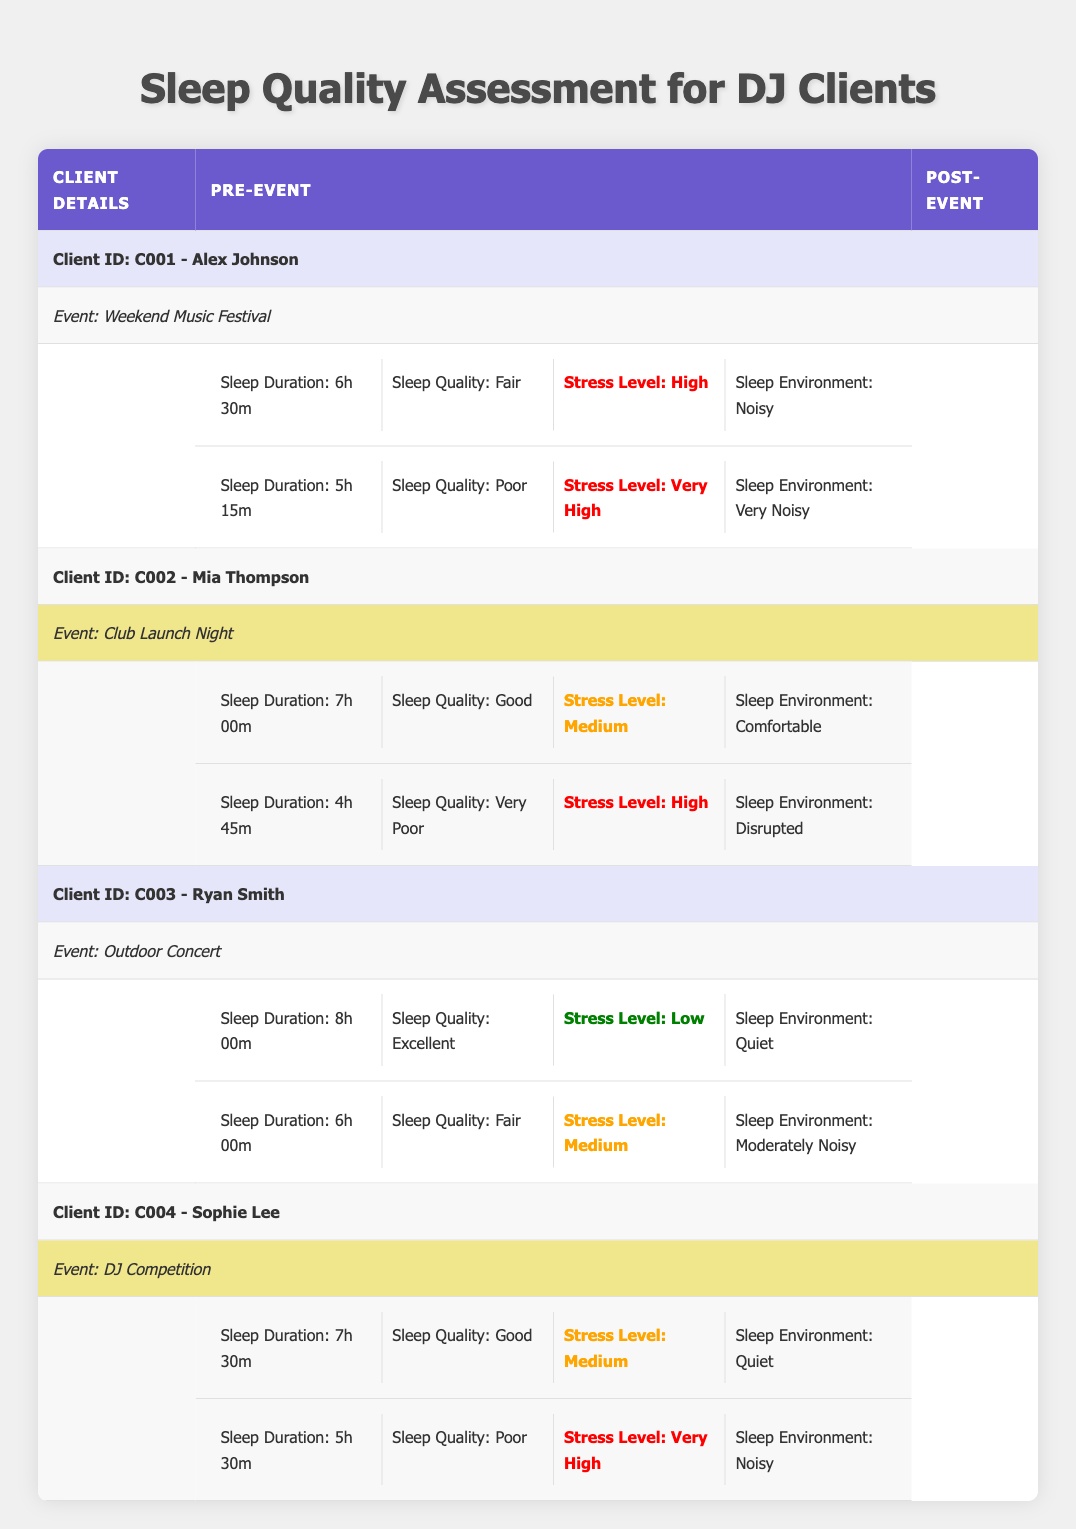What was Alex Johnson's sleep quality before the Weekend Music Festival? According to the table, Alex Johnson's sleep quality before the event was labeled as "Fair."
Answer: Fair Did Mia Thompson's sleep duration decrease after the Club Launch Night? Yes, Mia Thompson's sleep duration decreased from 7 hours to 4 hours and 45 minutes after the event.
Answer: Yes What is the difference in sleep quality for Ryan Smith before and after the Outdoor Concert? Ryan Smith's sleep quality changed from "Excellent" before the event to "Fair" after the event, indicating a decrease in quality.
Answer: Decreased What was the average sleep duration for all clients before the events? The sleep durations before the events were 6h 30m, 7h 00m, 8h 00m, and 7h 30m. Converting these to minutes: (390 + 420 + 480 + 450) = 1740 minutes. There are 4 clients, so the average is 1740/4 = 435 minutes, which converts back to 7 hours and 15 minutes.
Answer: 7h 15m Did all clients experience an increase in stress levels after their respective events? No, while Alex Johnson and Sophie Lee had their stress levels increase from High to Very High, Ryan Smith's stress level changed from Low to Medium, and Mia Thompson's stress level went from Medium to High.
Answer: No What type of sleep environment did Sophie Lee have before the DJ Competition? Sophie Lee had a "Quiet" sleep environment before the DJ Competition, according to the table.
Answer: Quiet What percentage of clients reported "Poor" sleep quality after their events? Out of the 4 clients, 2 reported "Poor" sleep quality after their events (Alex and Sophie). Thus, (2/4)*100% = 50%.
Answer: 50% Which client had the longest sleep duration before their event? Ryan Smith had the longest sleep duration before his event, which was 8 hours.
Answer: 8 hours What is the change in sleep duration for Sophie Lee from before to after the DJ Competition? Before the DJ Competition, Sophie Lee had a sleep duration of 7h 30m, which changed to 5h 30m after the event. This shows a change of 2 hours, resulting in a decrease.
Answer: Decreased by 2 hours 